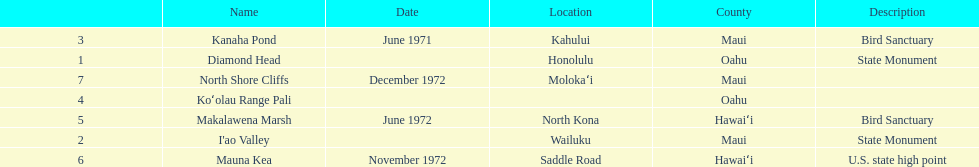What is the name of the only landmark that is also a u.s. state high point? Mauna Kea. 